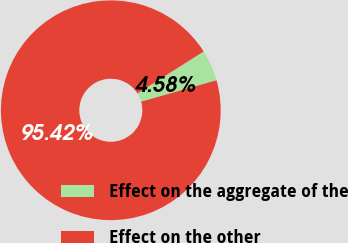Convert chart to OTSL. <chart><loc_0><loc_0><loc_500><loc_500><pie_chart><fcel>Effect on the aggregate of the<fcel>Effect on the other<nl><fcel>4.58%<fcel>95.42%<nl></chart> 